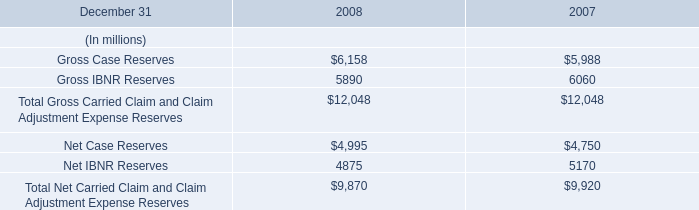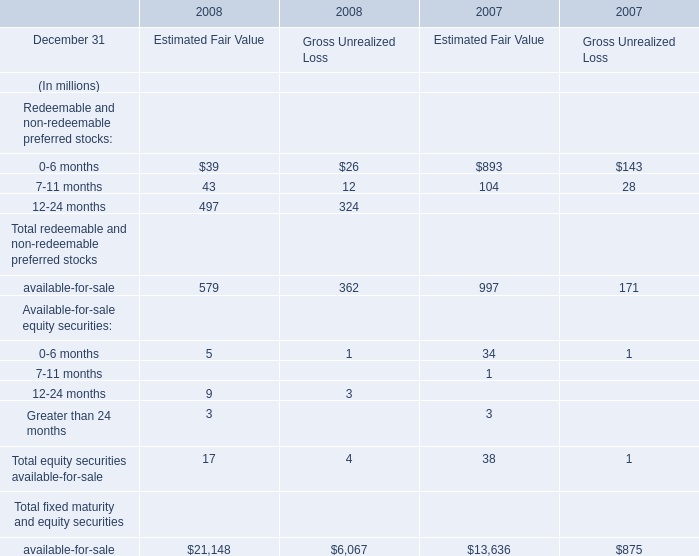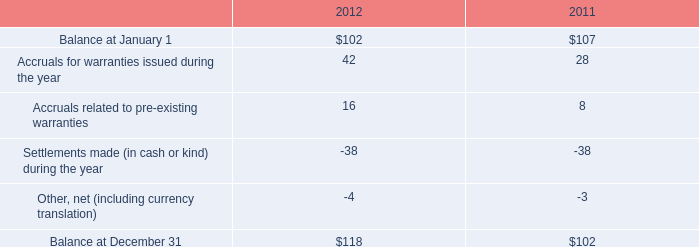What's the current increasing rate of 7-11 months of Redeemable and non-redeemable preferred stocks for Estimated Fair Value? 
Computations: ((43 - 104) / 104)
Answer: -0.58654. 